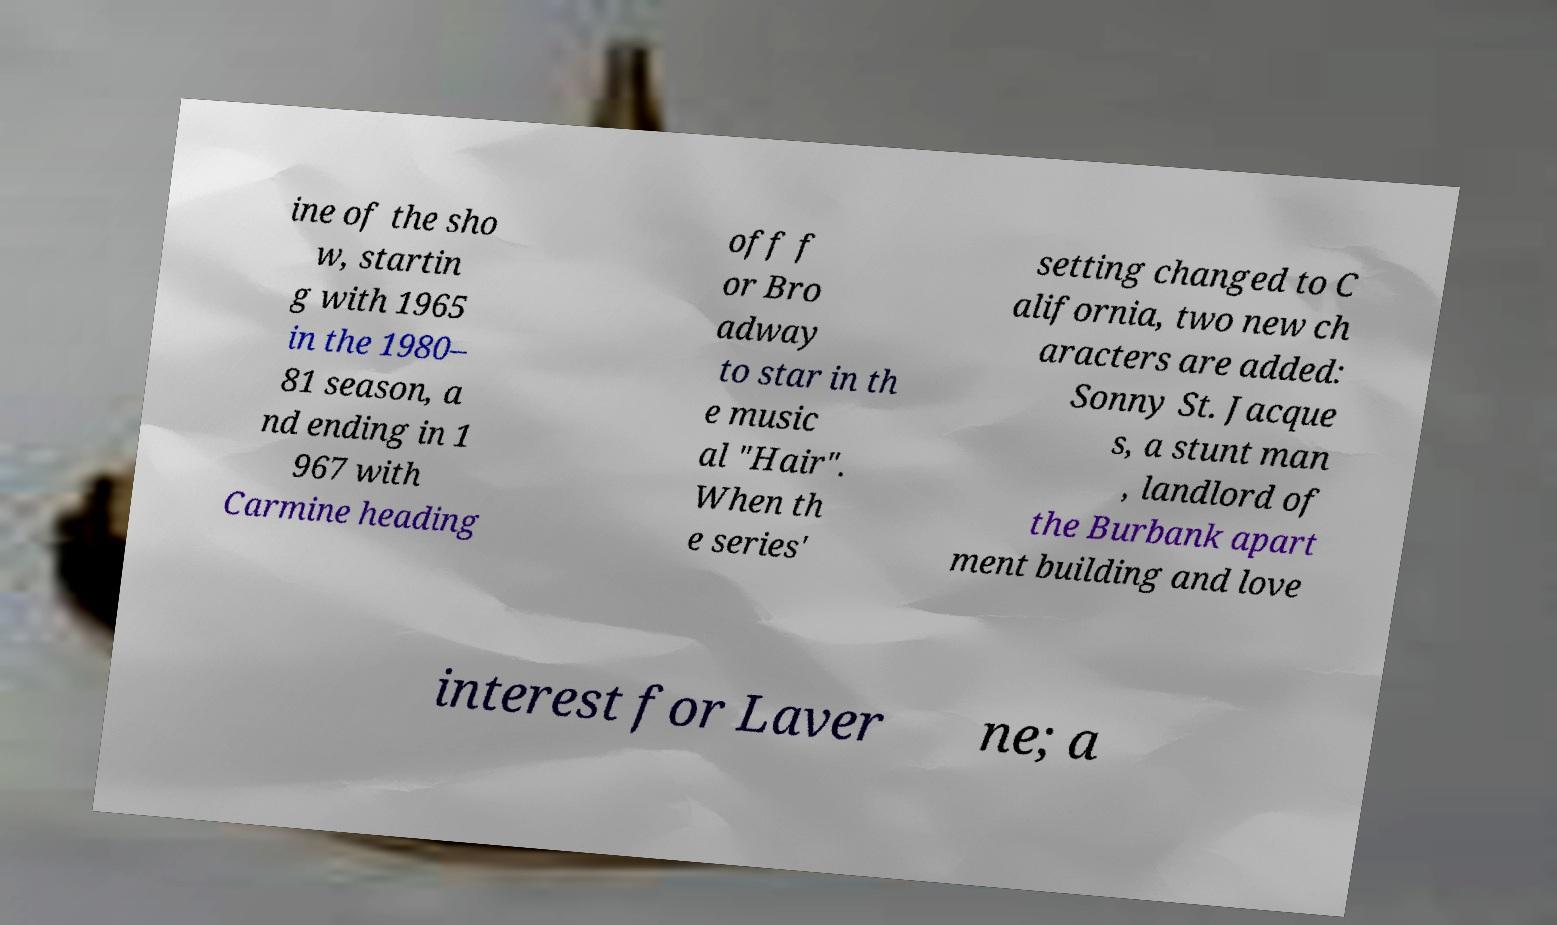For documentation purposes, I need the text within this image transcribed. Could you provide that? ine of the sho w, startin g with 1965 in the 1980– 81 season, a nd ending in 1 967 with Carmine heading off f or Bro adway to star in th e music al "Hair". When th e series' setting changed to C alifornia, two new ch aracters are added: Sonny St. Jacque s, a stunt man , landlord of the Burbank apart ment building and love interest for Laver ne; a 